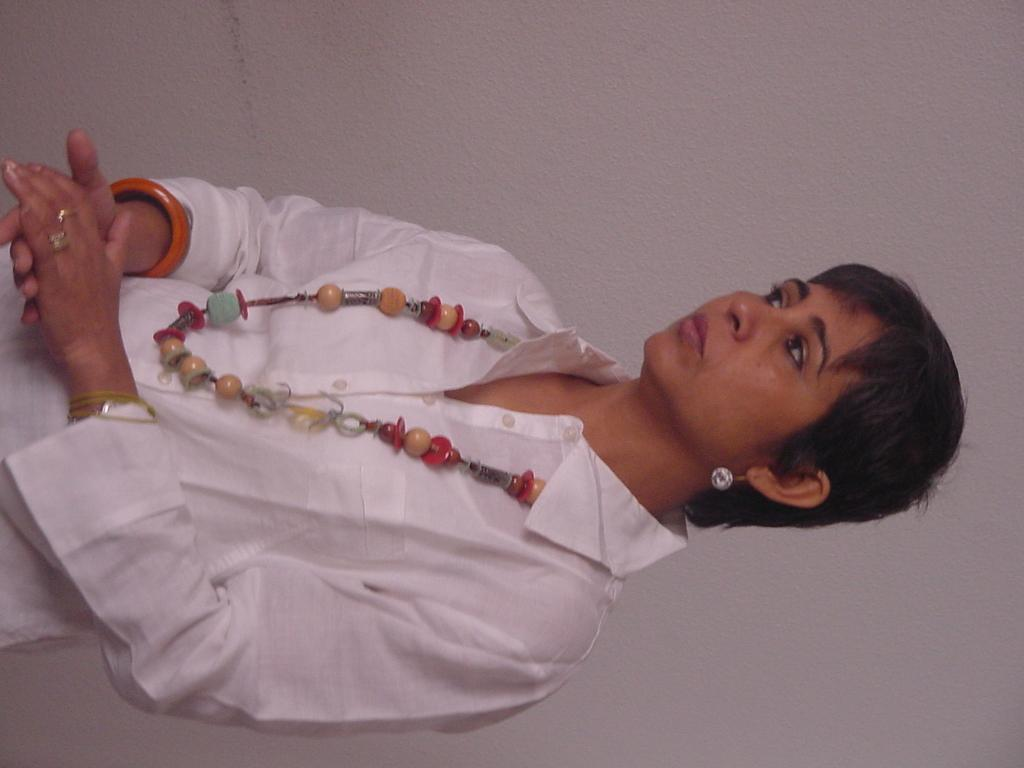What is the person in the image doing? The person is standing in the image. What is the person wearing on their upper body? The person is wearing a white shirt. What type of accessory is the person wearing? The person is wearing a chain. What can be seen in the background of the image? There is a wall in the background of the image. What color is the wall in the image? The wall is white in color. What type of thread is being used to sew the border of the person's shirt in the image? There is no mention of thread or a border on the person's shirt in the image. 